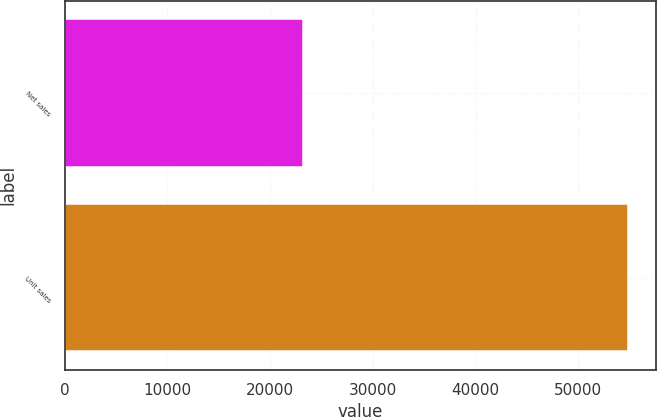Convert chart. <chart><loc_0><loc_0><loc_500><loc_500><bar_chart><fcel>Net sales<fcel>Unit sales<nl><fcel>23227<fcel>54856<nl></chart> 